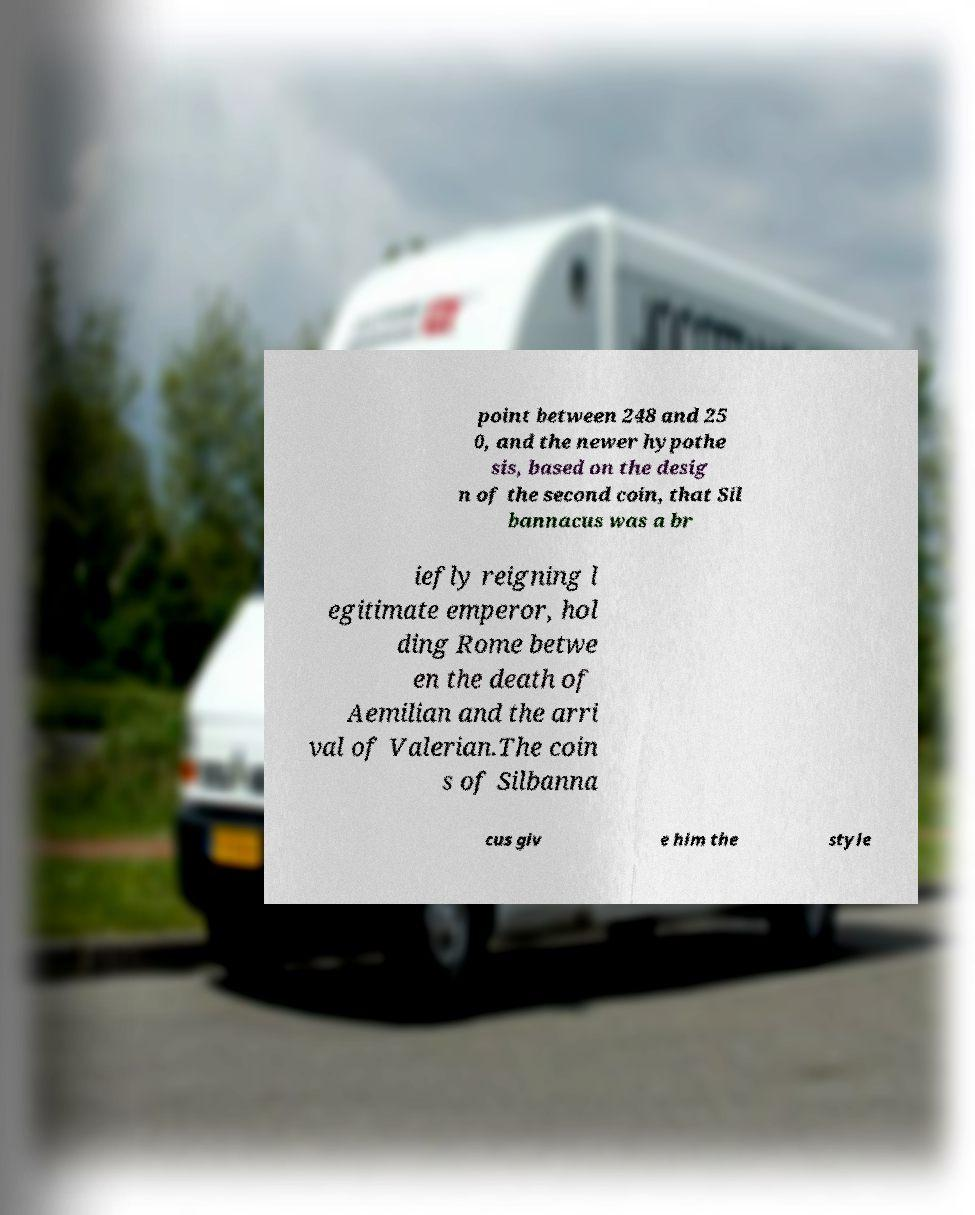Can you read and provide the text displayed in the image?This photo seems to have some interesting text. Can you extract and type it out for me? point between 248 and 25 0, and the newer hypothe sis, based on the desig n of the second coin, that Sil bannacus was a br iefly reigning l egitimate emperor, hol ding Rome betwe en the death of Aemilian and the arri val of Valerian.The coin s of Silbanna cus giv e him the style 